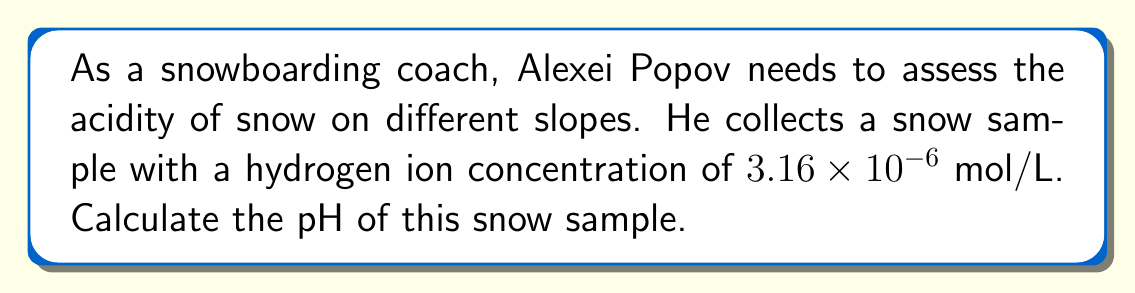Give your solution to this math problem. Let's approach this step-by-step:

1) The pH scale is defined as the negative logarithm (base 10) of the hydrogen ion concentration [H+]:

   $$ pH = -\log_{10}[H^+] $$

2) We're given that the hydrogen ion concentration is $3.16 \times 10^{-6}$ mol/L.

3) Let's substitute this into our pH equation:

   $$ pH = -\log_{10}(3.16 \times 10^{-6}) $$

4) Using the properties of logarithms, we can simplify this:

   $$ pH = -(\log_{10}(3.16) + \log_{10}(10^{-6})) $$

5) $\log_{10}(3.16)$ is approximately 0.5, and $\log_{10}(10^{-6}) = -6$

   $$ pH = -(0.5 + (-6)) = -0.5 + 6 = 5.5 $$

Therefore, the pH of the snow sample is 5.5.
Answer: 5.5 